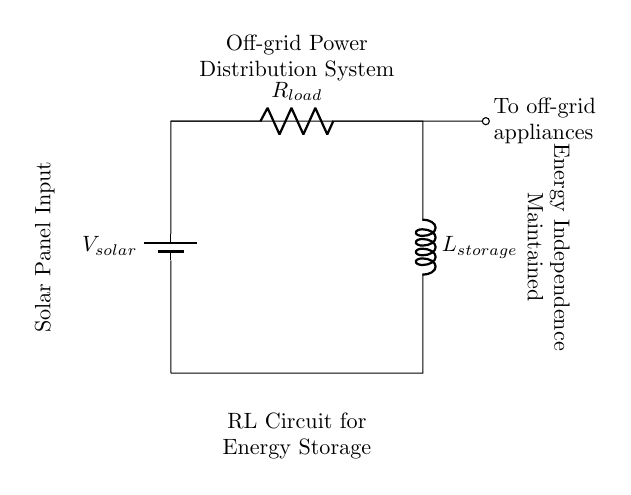What is the input voltage of the circuit? The input voltage is from the solar panel, denoted as V solar. This component provides the power needed to the circuit.
Answer: V solar What component stores energy in this circuit? The energy storage in the circuit is provided by the inductor, which is labeled as L storage. Inductors store energy in their magnetic fields when current flows through them.
Answer: L storage How many components are in this RL circuit? The circuit consists of three primary components: a battery (solar panel), a resistor (R load), and an inductor (L storage). This totals three components working together to distribute power.
Answer: Three What is the load component in this circuit? The load component is the resistor labeled R load, which represents the resistance that the circuit must drive current through to power off-grid appliances.
Answer: R load How does the circuit maintain energy independence? The circuit maintains energy independence by utilizing a solar panel input to directly power off-grid appliances while storing excess energy in the inductor, which is indicative of an off-grid configuration.
Answer: Off-grid configuration What role does the resistor play in this circuit? The resistor R load provides opposition to the current flow and determines how much current flows through the circuit, affecting the overall energy distribution to applications.
Answer: Current flow opposition 